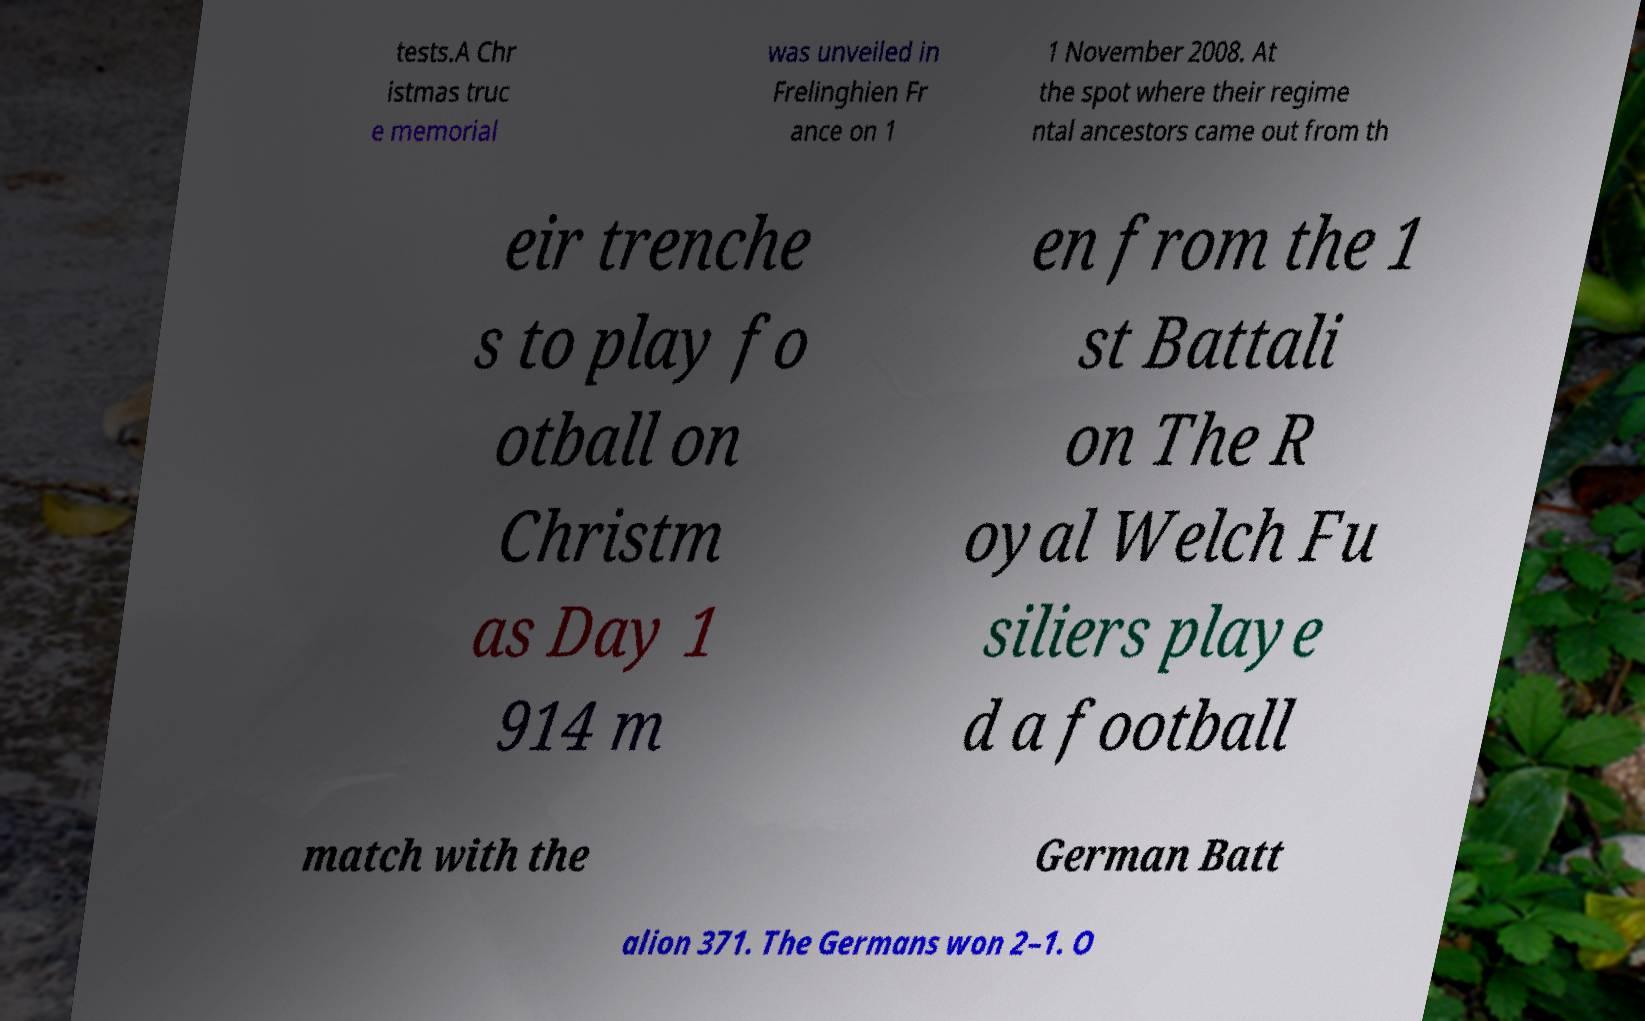Please read and relay the text visible in this image. What does it say? tests.A Chr istmas truc e memorial was unveiled in Frelinghien Fr ance on 1 1 November 2008. At the spot where their regime ntal ancestors came out from th eir trenche s to play fo otball on Christm as Day 1 914 m en from the 1 st Battali on The R oyal Welch Fu siliers playe d a football match with the German Batt alion 371. The Germans won 2–1. O 